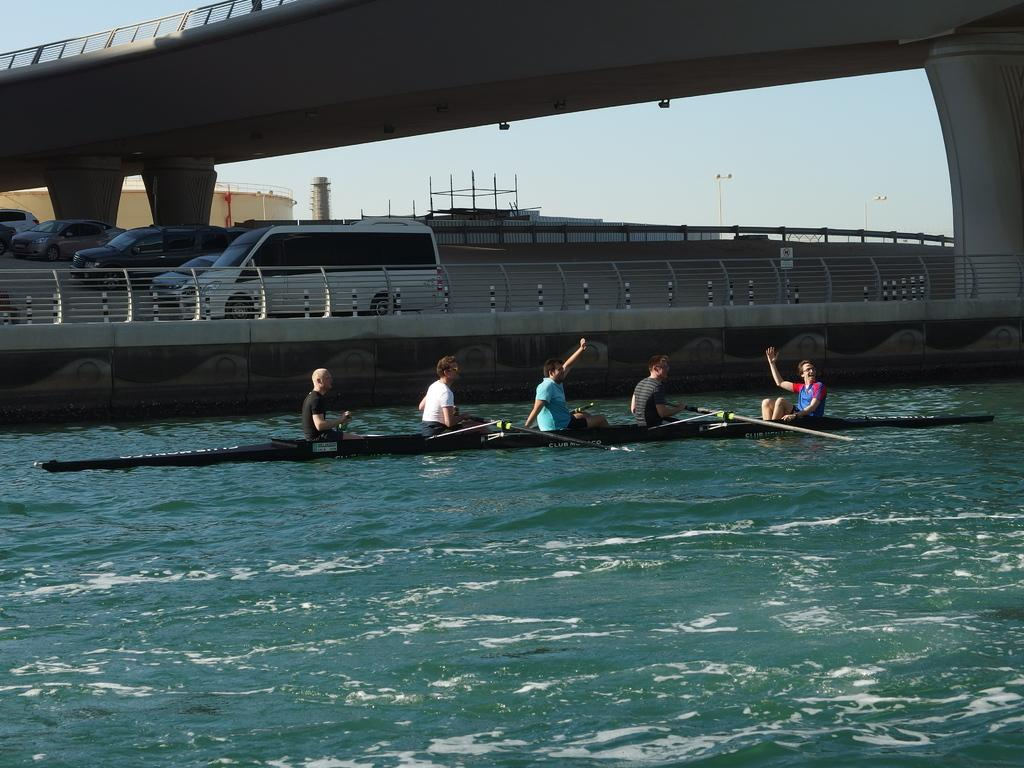What activity are the people in the image engaged in? The people in the image are sailing a boat. Where is the boat located? The boat is on the water. What can be seen in the background of the image? In the background of the image, there are vehicles, a road, railings, poles, pillars, a bridge, and the sky. What type of jewel is being used to decorate the boat in the image? There is no mention of any jewel being used to decorate the boat in the image. The image only shows a boat on the water with people sailing it, and various elements in the background. 